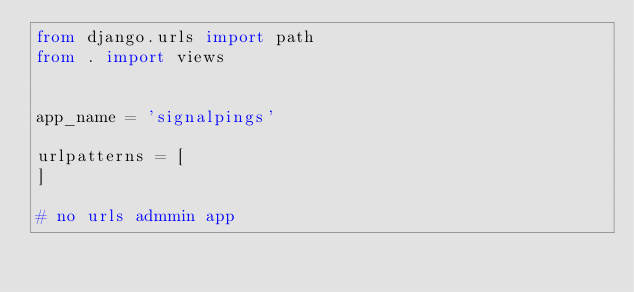<code> <loc_0><loc_0><loc_500><loc_500><_Python_>from django.urls import path
from . import views


app_name = 'signalpings'

urlpatterns = [
]

# no urls admmin app</code> 